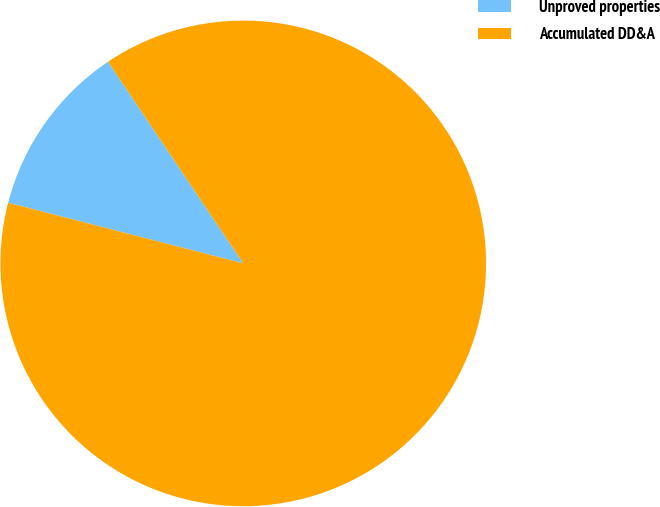Convert chart. <chart><loc_0><loc_0><loc_500><loc_500><pie_chart><fcel>Unproved properties<fcel>Accumulated DD&A<nl><fcel>11.58%<fcel>88.42%<nl></chart> 